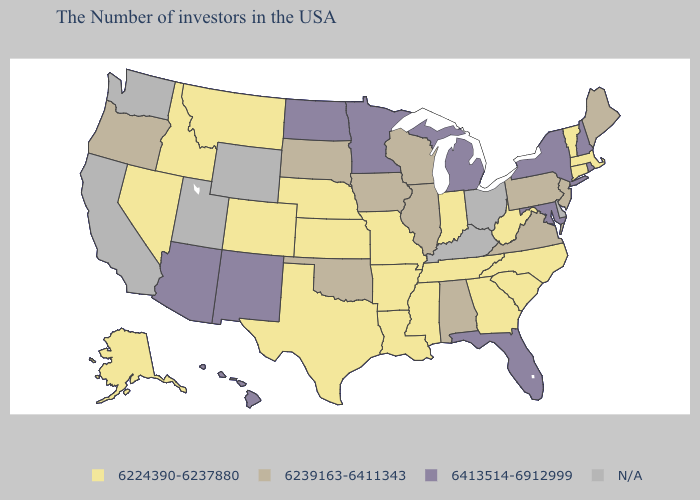Name the states that have a value in the range 6413514-6912999?
Answer briefly. Rhode Island, New Hampshire, New York, Maryland, Florida, Michigan, Minnesota, North Dakota, New Mexico, Arizona, Hawaii. Does North Carolina have the highest value in the USA?
Give a very brief answer. No. Among the states that border Minnesota , which have the highest value?
Be succinct. North Dakota. Does Michigan have the highest value in the MidWest?
Short answer required. Yes. What is the lowest value in the USA?
Quick response, please. 6224390-6237880. Does the first symbol in the legend represent the smallest category?
Quick response, please. Yes. Does Montana have the highest value in the West?
Short answer required. No. How many symbols are there in the legend?
Short answer required. 4. What is the highest value in states that border Arizona?
Write a very short answer. 6413514-6912999. Name the states that have a value in the range 6413514-6912999?
Give a very brief answer. Rhode Island, New Hampshire, New York, Maryland, Florida, Michigan, Minnesota, North Dakota, New Mexico, Arizona, Hawaii. Which states have the lowest value in the South?
Give a very brief answer. North Carolina, South Carolina, West Virginia, Georgia, Tennessee, Mississippi, Louisiana, Arkansas, Texas. What is the value of West Virginia?
Keep it brief. 6224390-6237880. What is the value of South Carolina?
Answer briefly. 6224390-6237880. Name the states that have a value in the range N/A?
Write a very short answer. Delaware, Ohio, Kentucky, Wyoming, Utah, California, Washington. What is the value of Rhode Island?
Short answer required. 6413514-6912999. 